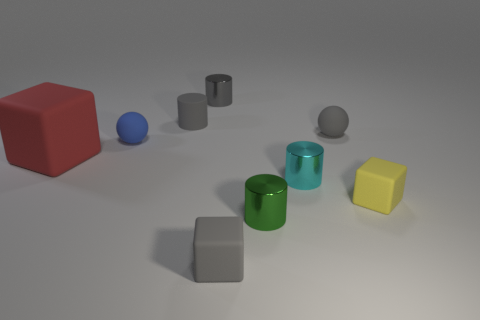There is a small gray rubber thing that is in front of the yellow block; what is its shape?
Provide a short and direct response. Cube. There is a gray object that is both behind the big block and right of the gray metal object; what shape is it?
Ensure brevity in your answer.  Sphere. How many brown objects are either tiny things or small metallic cylinders?
Provide a short and direct response. 0. There is a metallic cylinder behind the red rubber thing; does it have the same color as the large block?
Ensure brevity in your answer.  No. How big is the cylinder to the left of the small metal object behind the red rubber thing?
Provide a succinct answer. Small. What material is the green thing that is the same size as the blue rubber thing?
Provide a short and direct response. Metal. How many other objects are there of the same size as the gray metal cylinder?
Ensure brevity in your answer.  7. What number of cubes are big objects or small yellow rubber objects?
Your response must be concise. 2. Is there any other thing that has the same material as the green cylinder?
Offer a very short reply. Yes. What material is the small block that is behind the small matte block that is in front of the small block behind the green shiny cylinder?
Ensure brevity in your answer.  Rubber. 